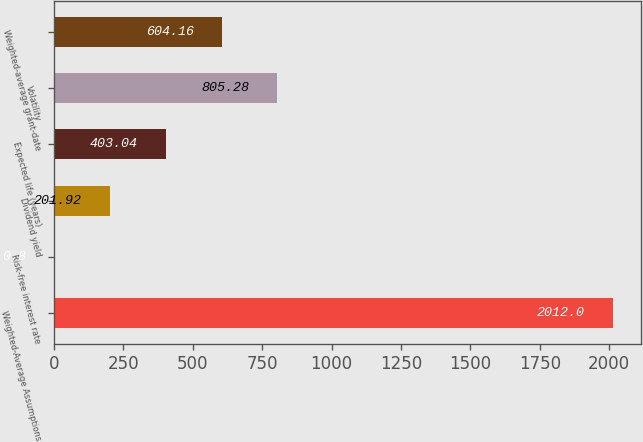Convert chart to OTSL. <chart><loc_0><loc_0><loc_500><loc_500><bar_chart><fcel>Weighted-Average Assumptions<fcel>Risk-free interest rate<fcel>Dividend yield<fcel>Expected life (years)<fcel>Volatility<fcel>Weighted-average grant-date<nl><fcel>2012<fcel>0.8<fcel>201.92<fcel>403.04<fcel>805.28<fcel>604.16<nl></chart> 